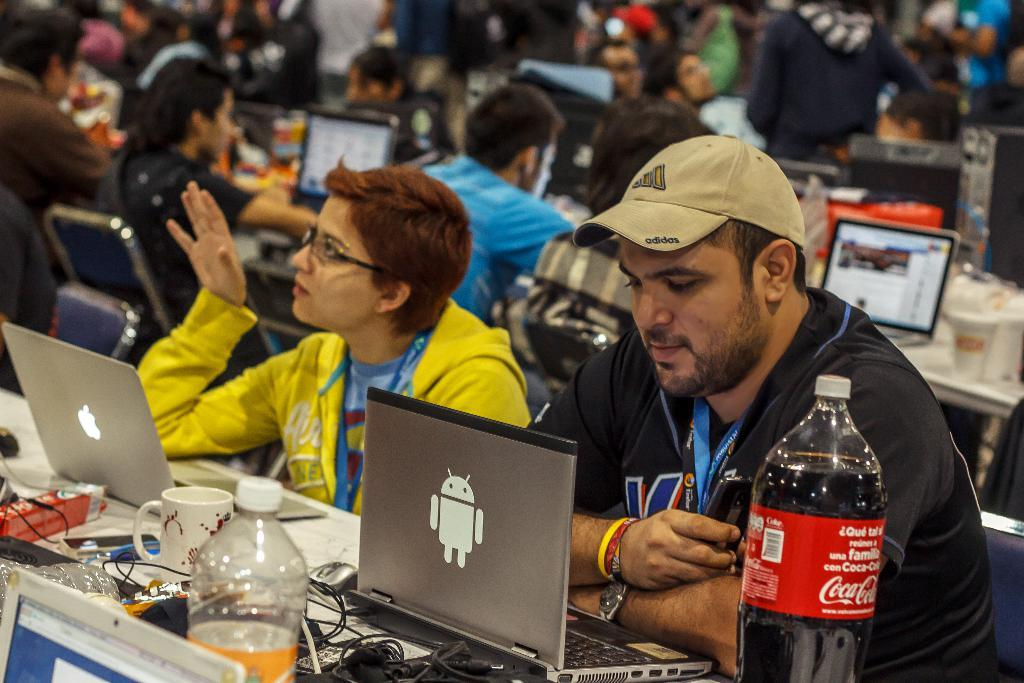What are the people in the image doing? The people in the image are sitting on chairs. Where are the chairs located in relation to the table? The chairs are in front of the table. What electronic devices can be seen on the table? There are laptops on the table. What else can be found on the table besides laptops? There are wires, cups, bottles, and a mouse on the table. Are there any other objects on the table? Yes, there are other objects on the table. Can you see any coal being used in the image? No, there is no coal present in the image. Are the people in the image kicking a soccer ball? No, the people in the image are sitting on chairs and not engaging in any physical activity. 